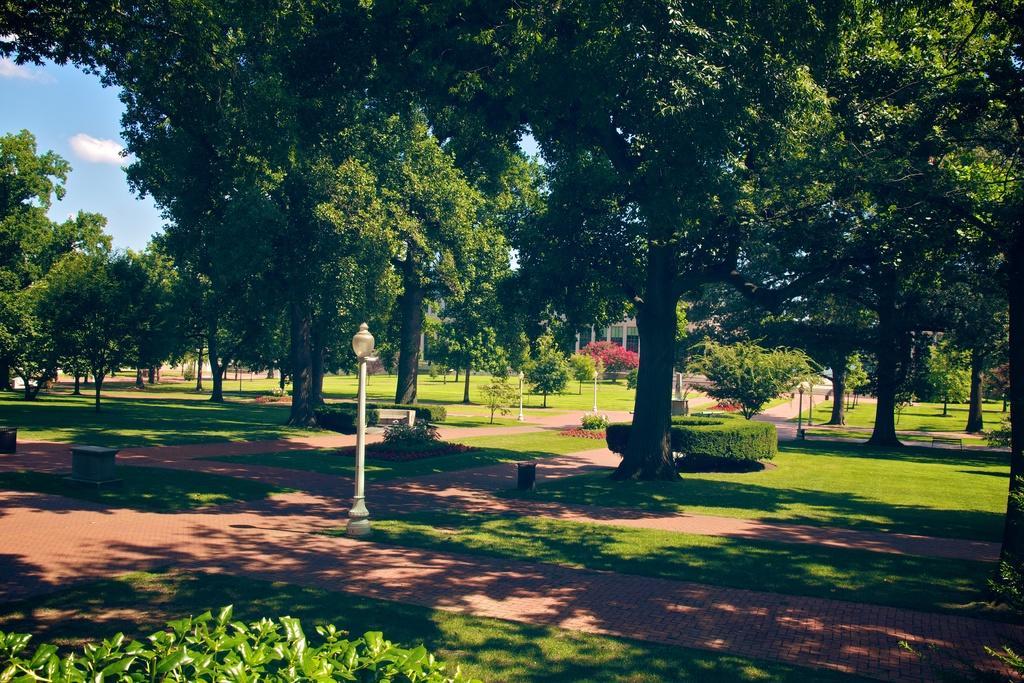Could you give a brief overview of what you see in this image? In this image, we can see trees, light poles, plants and buildings and we can see a bench and some stones on the ground. At the top, there are clouds in the sky. 